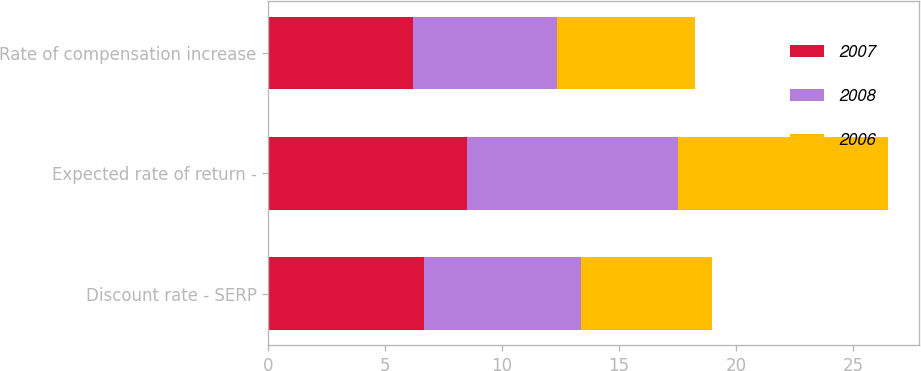Convert chart to OTSL. <chart><loc_0><loc_0><loc_500><loc_500><stacked_bar_chart><ecel><fcel>Discount rate - SERP<fcel>Expected rate of return -<fcel>Rate of compensation increase<nl><fcel>2007<fcel>6.64<fcel>8.5<fcel>6.17<nl><fcel>2008<fcel>6.73<fcel>9<fcel>6.17<nl><fcel>2006<fcel>5.6<fcel>9<fcel>5.89<nl></chart> 